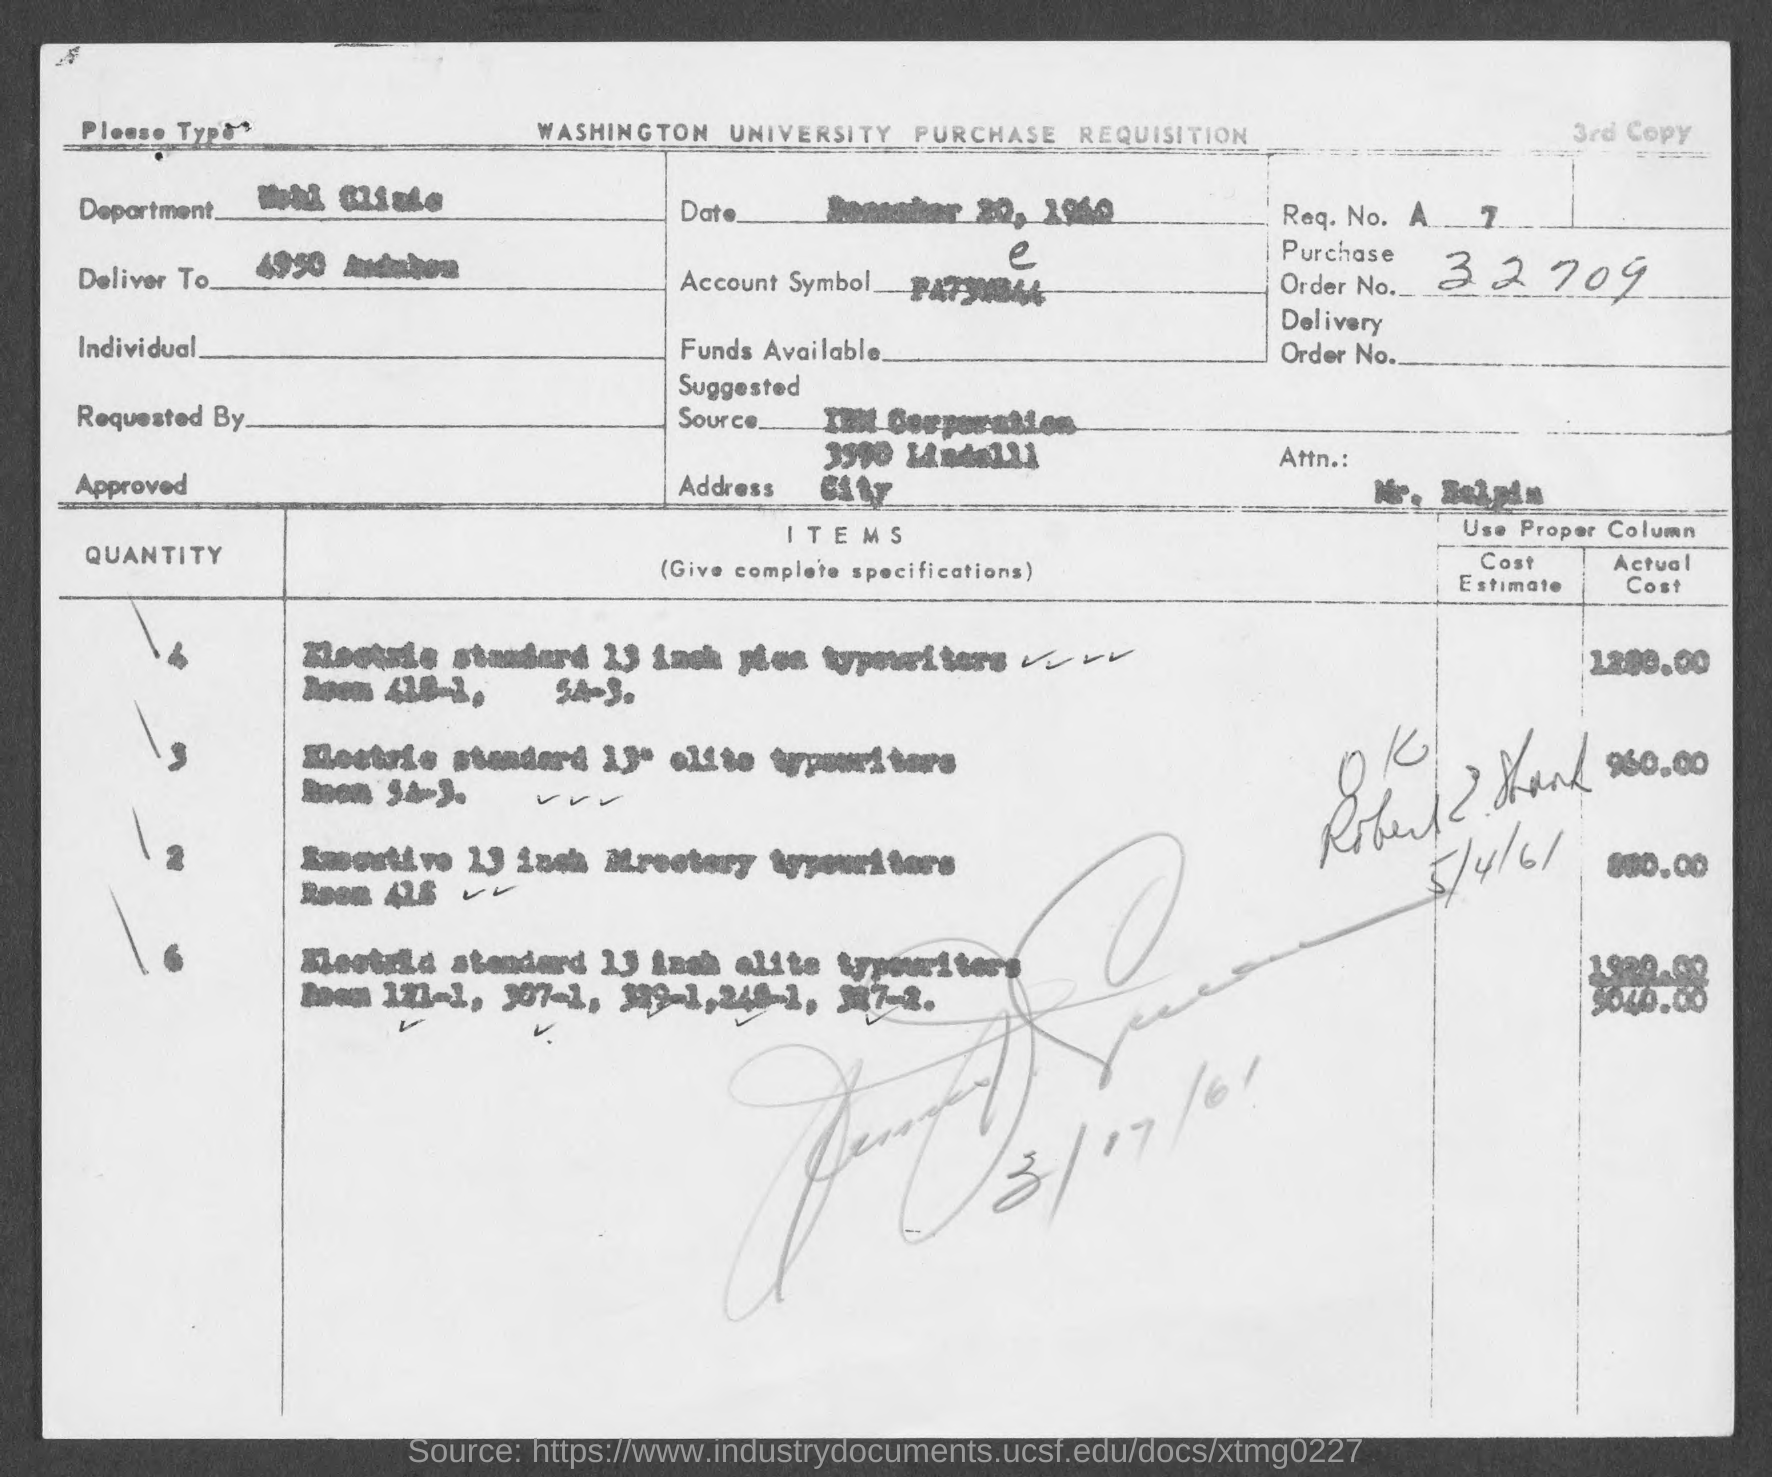What is the Order No. ?
Your answer should be compact. 32709. 